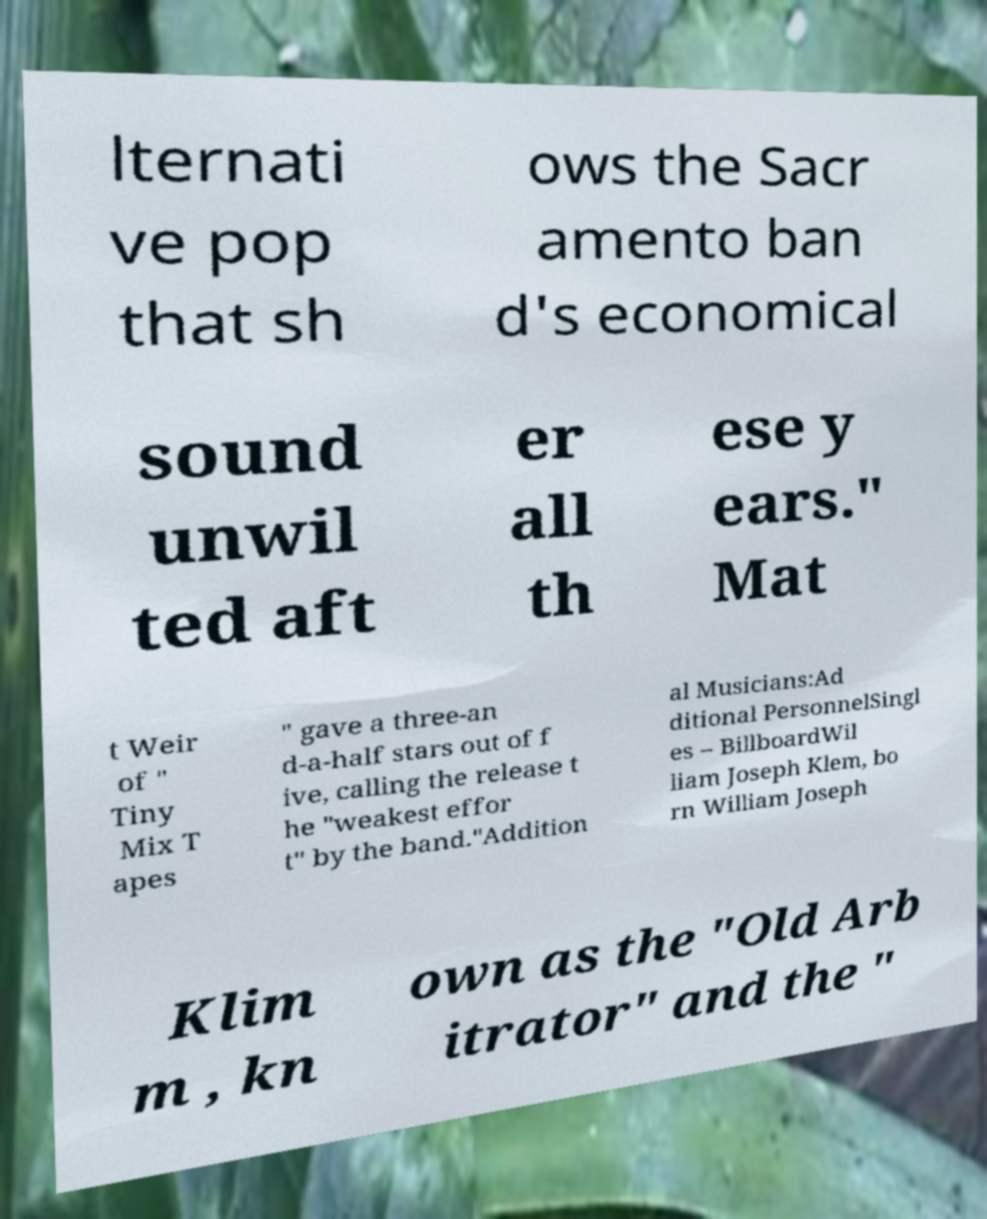Could you assist in decoding the text presented in this image and type it out clearly? lternati ve pop that sh ows the Sacr amento ban d's economical sound unwil ted aft er all th ese y ears." Mat t Weir of " Tiny Mix T apes " gave a three-an d-a-half stars out of f ive, calling the release t he "weakest effor t" by the band."Addition al Musicians:Ad ditional PersonnelSingl es – BillboardWil liam Joseph Klem, bo rn William Joseph Klim m , kn own as the "Old Arb itrator" and the " 